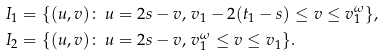Convert formula to latex. <formula><loc_0><loc_0><loc_500><loc_500>I _ { 1 } & = \{ ( u , v ) \colon \, u = 2 s - v , \, v _ { 1 } - 2 ( t _ { 1 } - s ) \leq v \leq v _ { 1 } ^ { \omega } \} , \\ I _ { 2 } & = \{ ( u , v ) \colon \, u = 2 s - v , \, v _ { 1 } ^ { \omega } \leq v \leq v _ { 1 } \} .</formula> 